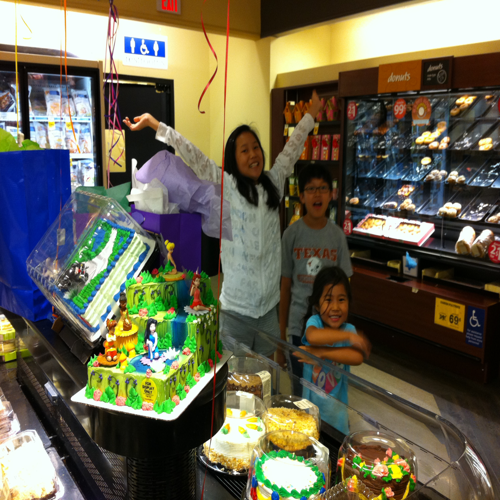Are there any quality issues with this image? The image appears to be of low resolution, which affects the sharpness and detail visibility. There is also a significant glare, possibly from overhead lighting, on the cake's surface, and the exposure seems uneven with some areas over-illuminated. Furthermore, the composition is slightly cluttered, causing a distraction from the central subjects. 